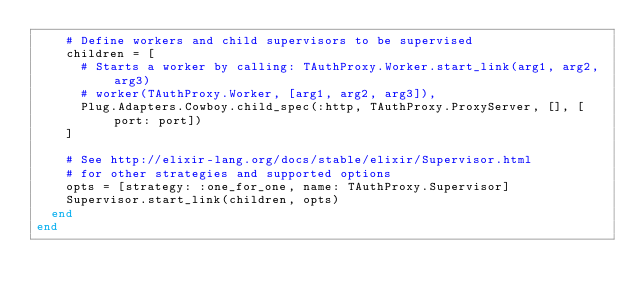<code> <loc_0><loc_0><loc_500><loc_500><_Elixir_>    # Define workers and child supervisors to be supervised
    children = [
      # Starts a worker by calling: TAuthProxy.Worker.start_link(arg1, arg2, arg3)
      # worker(TAuthProxy.Worker, [arg1, arg2, arg3]),
      Plug.Adapters.Cowboy.child_spec(:http, TAuthProxy.ProxyServer, [], [port: port])
    ]

    # See http://elixir-lang.org/docs/stable/elixir/Supervisor.html
    # for other strategies and supported options
    opts = [strategy: :one_for_one, name: TAuthProxy.Supervisor]
    Supervisor.start_link(children, opts)
  end
end
</code> 